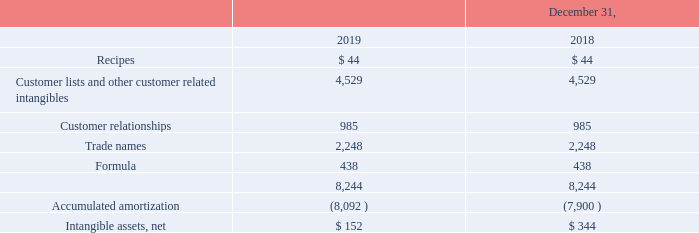Finite-lived Intangible Assets
Other intangible assets, net consisted of the following:
The remaining $152 of intangible asset at December 31, 2019 is expected to be amortized in 2020.
What is the value of the intangible asset at December 31, 2019 expected to be amortized in 2020? $152. What is the value of recipes in 2018 and 2019 respectively? $ 44, $ 44. What is the value of customer relationships in 2018 and 2019 respectively? 985, 985. What is the change in the value of customer relationships between 2018 and 2019? 985-985
Answer: 0. What is the average value of trade names for both 2018 and 2019? (2,248+2,248)/2
Answer: 2248. Which year has a higher value of net intangible assets? Compare the net intangible assets value between the years
Answer: 2018. 